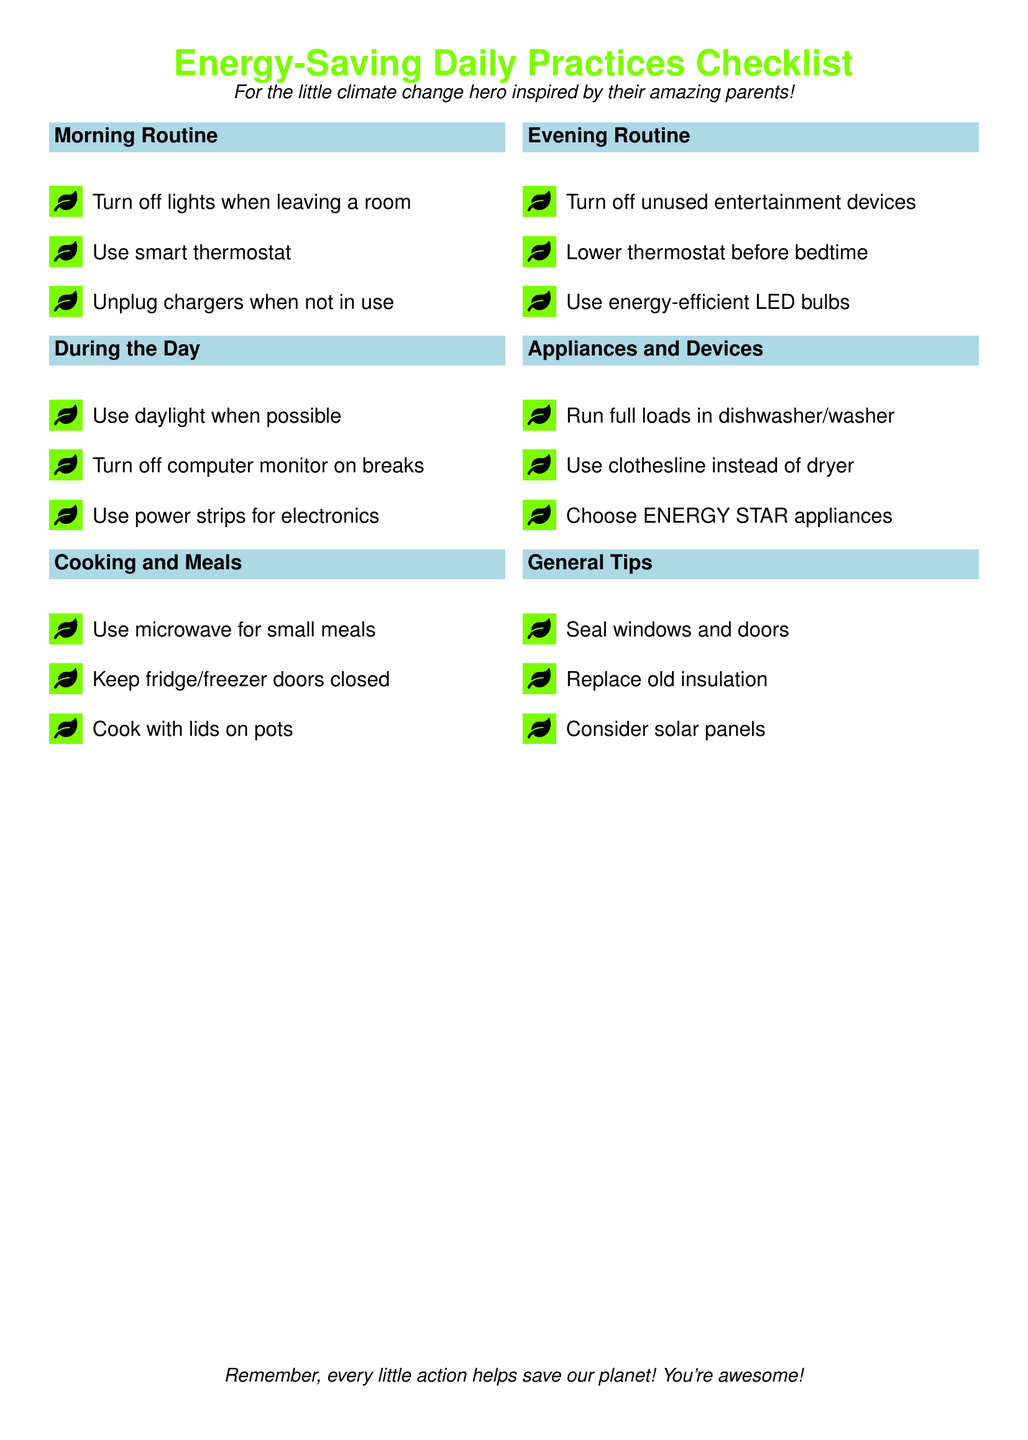What is the title of the checklist? The title is at the beginning of the document and indicates the subject of the content.
Answer: Energy-Saving Daily Practices Checklist How many sections are there in the checklist? By counting the labeled sections in the document, we can determine the total number.
Answer: Six What is one energy-saving tip from the morning routine? The morning routine section includes tips for saving energy in the morning.
Answer: Turn off lights when leaving a room What should you use during the day to save energy? This question asks for an energy-saving practice mentioned specifically in the daytime section.
Answer: Daylight What type of bulbs does the evening routine recommend? This part of the checklist suggests specific types of light bulbs for use in the evening.
Answer: Energy-efficient LED bulbs Which appliance is suggested to run with full loads? The checklist specifies actions for maximizing energy use in specific appliances.
Answer: Dishwasher/washer What is a general tip provided in the checklist? This encourages recalling a general energy-saving tip mentioned in the document.
Answer: Seal windows and doors Name one cooking tip from the cooking and meals section. The cooking section contains several tips related to energy-saving while cooking.
Answer: Use microwave for small meals 